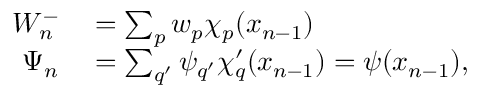<formula> <loc_0><loc_0><loc_500><loc_500>\begin{array} { r l } { W _ { n } ^ { - } } & = \sum _ { p } w _ { p } \chi _ { p } ( x _ { n - 1 } ) } \\ { \Psi _ { n } } & = \sum _ { q ^ { \prime } } \psi _ { q ^ { \prime } } \chi { _ { q } ^ { \prime } } ( x _ { n - 1 } ) = \psi ( x _ { n - 1 } ) , } \end{array}</formula> 